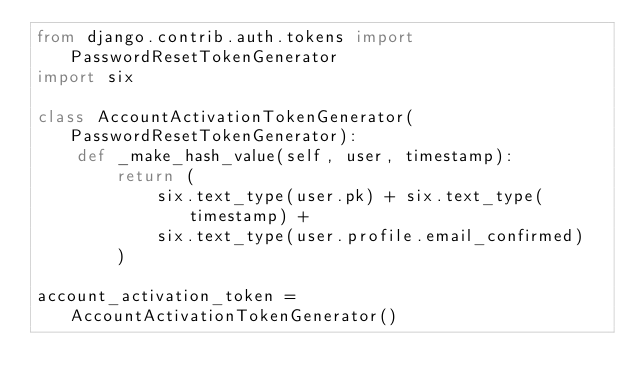Convert code to text. <code><loc_0><loc_0><loc_500><loc_500><_Python_>from django.contrib.auth.tokens import PasswordResetTokenGenerator
import six

class AccountActivationTokenGenerator(PasswordResetTokenGenerator):
    def _make_hash_value(self, user, timestamp):
        return (
            six.text_type(user.pk) + six.text_type(timestamp) +
            six.text_type(user.profile.email_confirmed)
        )

account_activation_token = AccountActivationTokenGenerator()</code> 